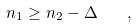<formula> <loc_0><loc_0><loc_500><loc_500>n _ { 1 } \geq n _ { 2 } - \Delta \quad ,</formula> 